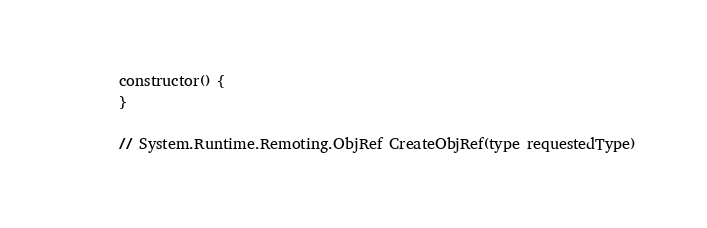<code> <loc_0><loc_0><loc_500><loc_500><_JavaScript_>    constructor() {
    }

    // System.Runtime.Remoting.ObjRef CreateObjRef(type requestedType)</code> 